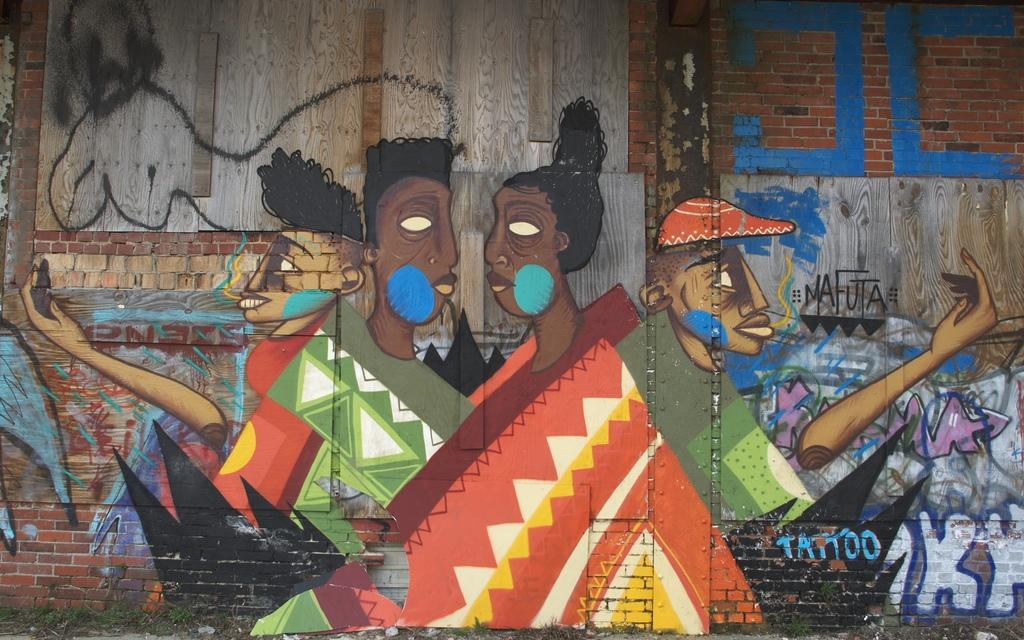What can be seen on the wall in the image? There are paintings on the wall in the image. What type of pot is being used to bake pies in the image? There is no pot or pies present in the image; it only features paintings on the wall. 